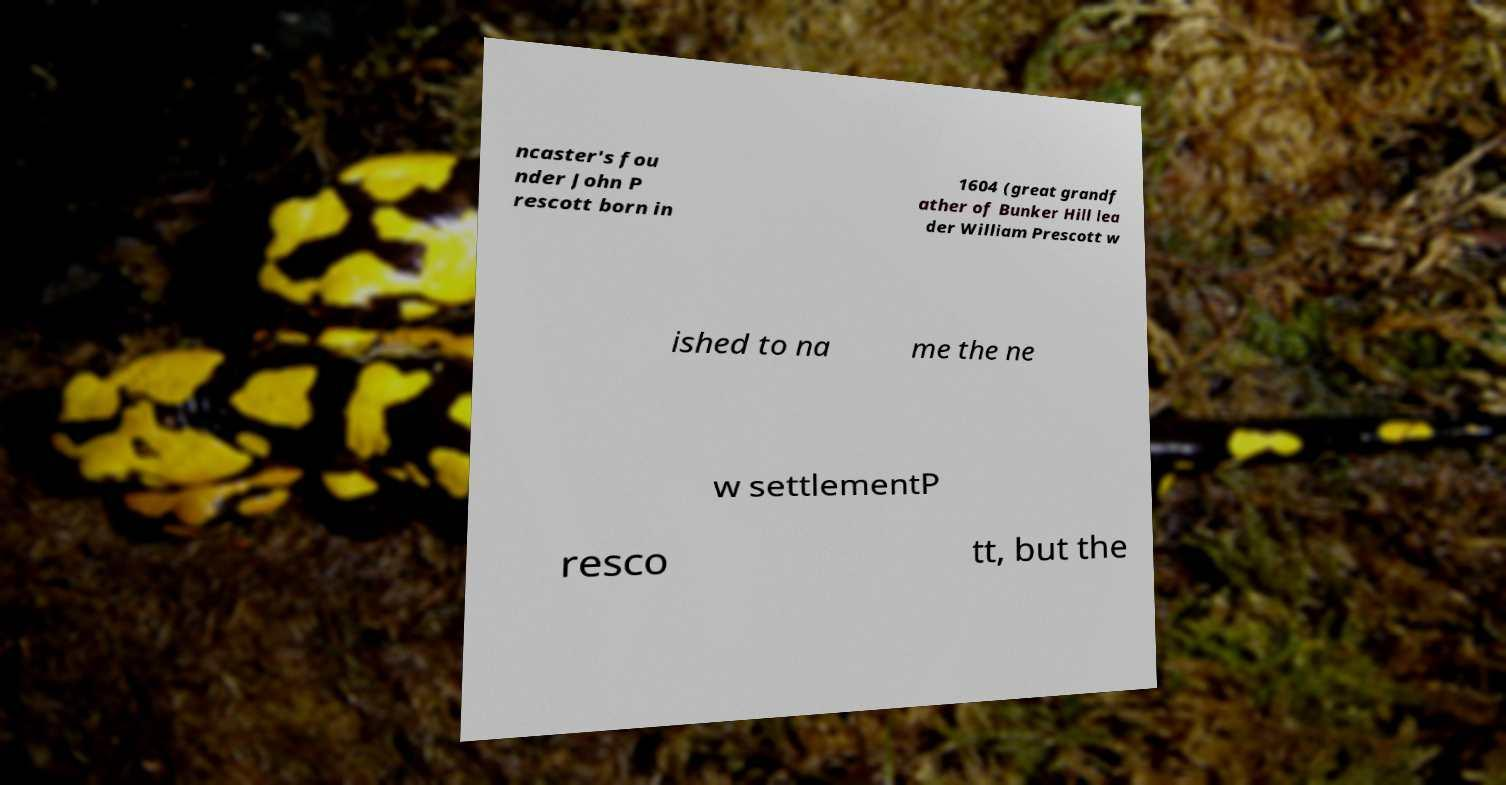Could you extract and type out the text from this image? ncaster's fou nder John P rescott born in 1604 (great grandf ather of Bunker Hill lea der William Prescott w ished to na me the ne w settlementP resco tt, but the 